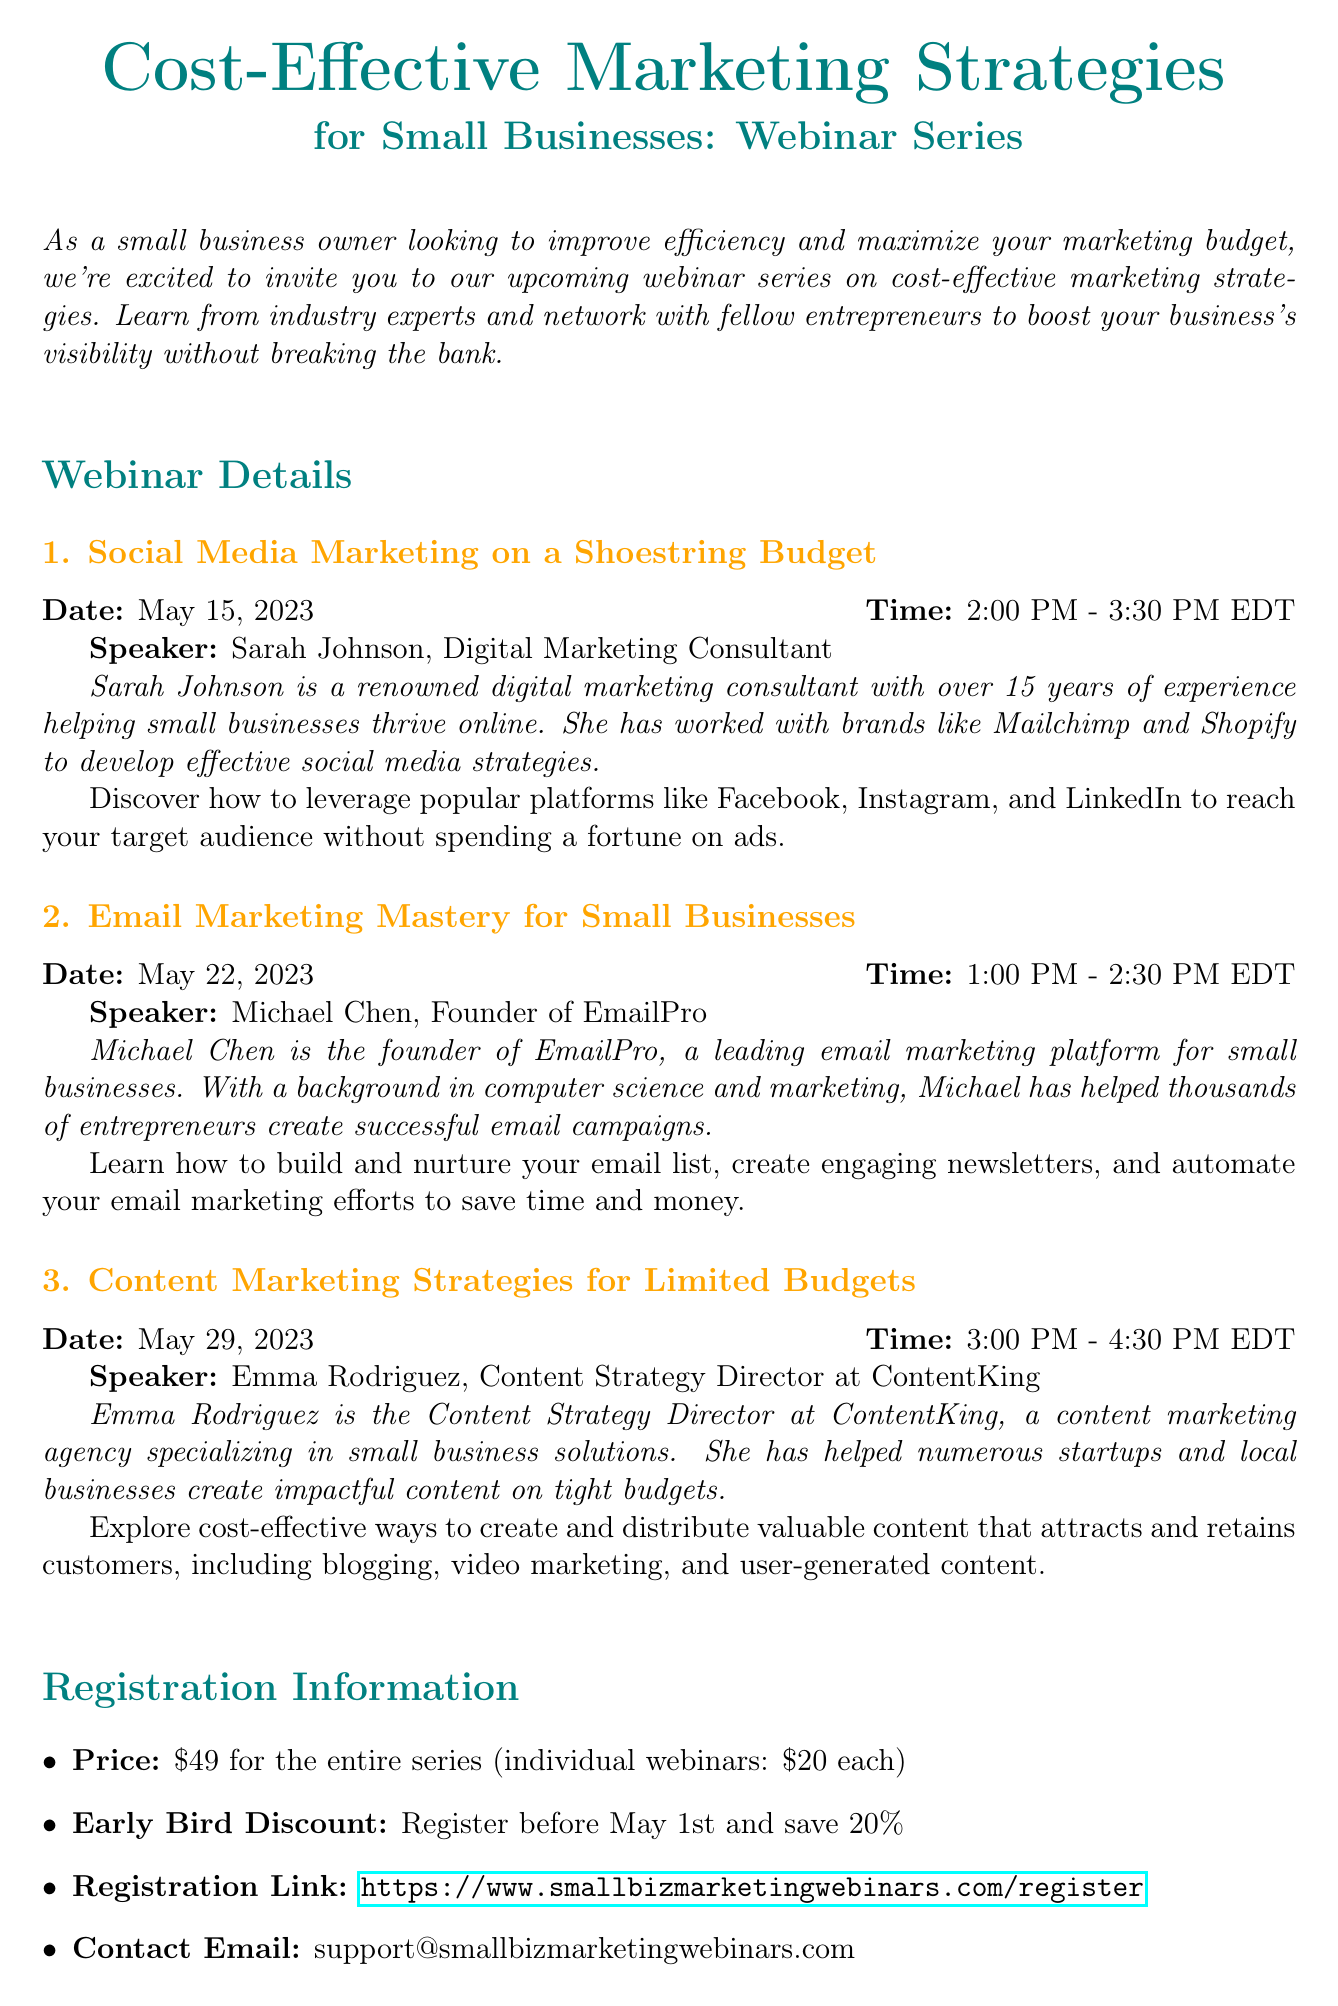What is the title of the webinar series? The title of the webinar series is specified in the document as "Cost-Effective Marketing Strategies for Small Businesses: Webinar Series."
Answer: Cost-Effective Marketing Strategies for Small Businesses: Webinar Series Who is the speaker for the webinar on social media marketing? The document lists Sarah Johnson as the speaker for the social media marketing webinar.
Answer: Sarah Johnson What is the price for the entire series of webinars? The document states the price for the entire series as $49.
Answer: $49 When does the webinar on email marketing take place? The document specifies the date of the email marketing webinar as May 22, 2023.
Answer: May 22, 2023 What discount is available for early registration? The document mentions a 20% discount for early registration before May 1st.
Answer: 20% What is the duration of the content marketing strategies webinar? The document states the content marketing strategies webinar is from 3:00 PM to 4:30 PM EDT, which is 1.5 hours.
Answer: 1.5 hours What is one of the additional resources mentioned in the newsletter? The document lists "Free Marketing Tools for Small Businesses" as one of the additional resources.
Answer: Free Marketing Tools for Small Businesses Who provided a testimonial about the webinars? The testimonial in the document is given by John Smith, who is the owner of Smith's Bakery.
Answer: John Smith What is the registration link for the webinar series? The document provides a specific URL for registration, which is www.smallbizmarketingwebinars.com/register.
Answer: www.smallbizmarketingwebinars.com/register 